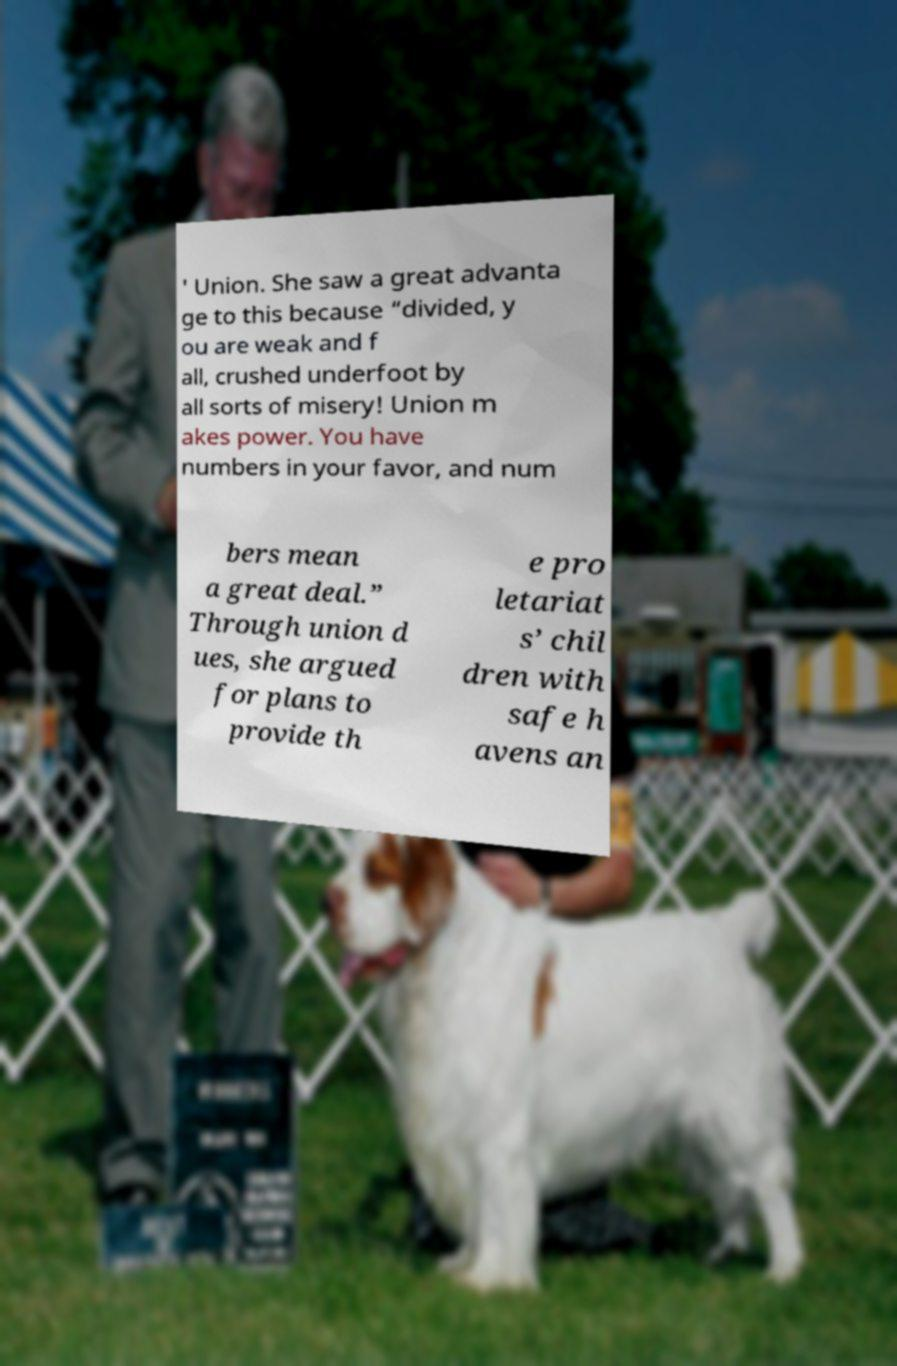For documentation purposes, I need the text within this image transcribed. Could you provide that? ' Union. She saw a great advanta ge to this because “divided, y ou are weak and f all, crushed underfoot by all sorts of misery! Union m akes power. You have numbers in your favor, and num bers mean a great deal.” Through union d ues, she argued for plans to provide th e pro letariat s’ chil dren with safe h avens an 